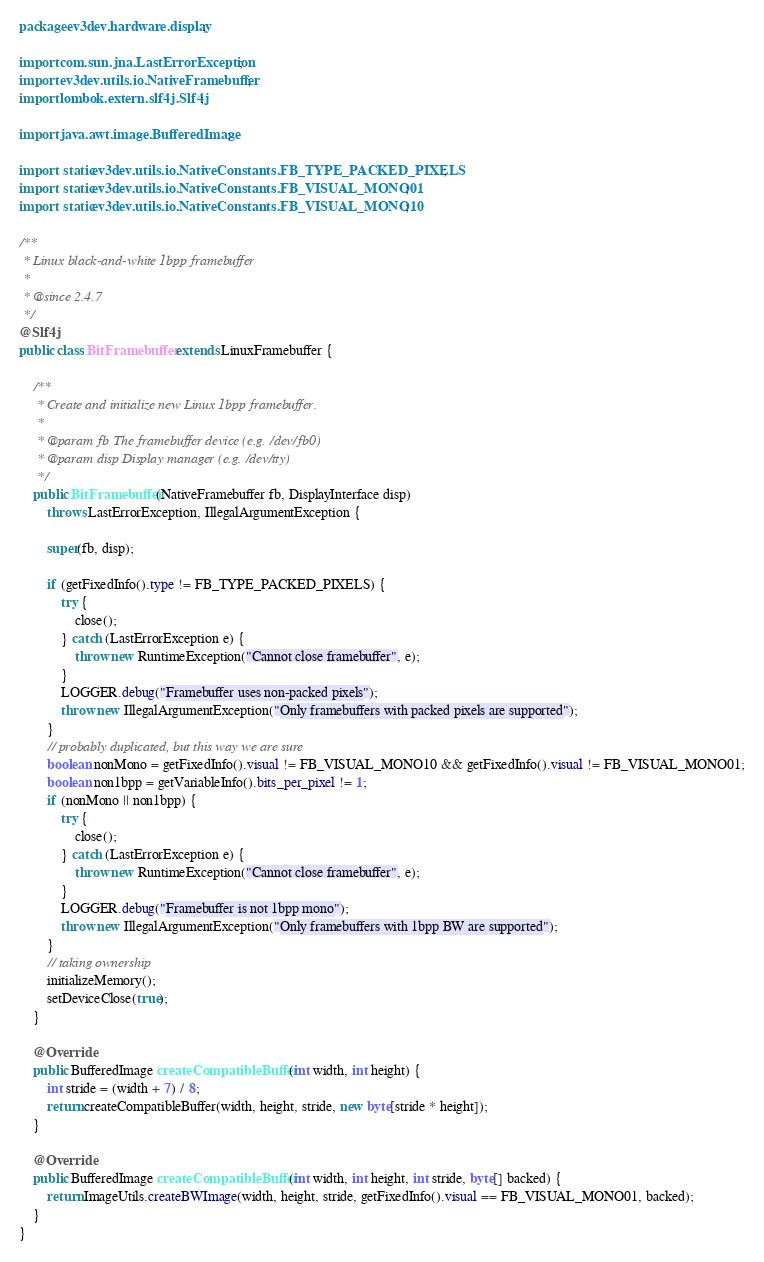<code> <loc_0><loc_0><loc_500><loc_500><_Java_>package ev3dev.hardware.display;

import com.sun.jna.LastErrorException;
import ev3dev.utils.io.NativeFramebuffer;
import lombok.extern.slf4j.Slf4j;

import java.awt.image.BufferedImage;

import static ev3dev.utils.io.NativeConstants.FB_TYPE_PACKED_PIXELS;
import static ev3dev.utils.io.NativeConstants.FB_VISUAL_MONO01;
import static ev3dev.utils.io.NativeConstants.FB_VISUAL_MONO10;

/**
 * Linux black-and-white 1bpp framebuffer
 *
 * @since 2.4.7
 */
@Slf4j
public class BitFramebuffer extends LinuxFramebuffer {

    /**
     * Create and initialize new Linux 1bpp framebuffer.
     *
     * @param fb The framebuffer device (e.g. /dev/fb0)
     * @param disp Display manager (e.g. /dev/tty)
     */
    public BitFramebuffer(NativeFramebuffer fb, DisplayInterface disp)
        throws LastErrorException, IllegalArgumentException {

        super(fb, disp);

        if (getFixedInfo().type != FB_TYPE_PACKED_PIXELS) {
            try {
                close();
            } catch (LastErrorException e) {
                throw new RuntimeException("Cannot close framebuffer", e);
            }
            LOGGER.debug("Framebuffer uses non-packed pixels");
            throw new IllegalArgumentException("Only framebuffers with packed pixels are supported");
        }
        // probably duplicated, but this way we are sure
        boolean nonMono = getFixedInfo().visual != FB_VISUAL_MONO10 && getFixedInfo().visual != FB_VISUAL_MONO01;
        boolean non1bpp = getVariableInfo().bits_per_pixel != 1;
        if (nonMono || non1bpp) {
            try {
                close();
            } catch (LastErrorException e) {
                throw new RuntimeException("Cannot close framebuffer", e);
            }
            LOGGER.debug("Framebuffer is not 1bpp mono");
            throw new IllegalArgumentException("Only framebuffers with 1bpp BW are supported");
        }
        // taking ownership
        initializeMemory();
        setDeviceClose(true);
    }

    @Override
    public BufferedImage createCompatibleBuffer(int width, int height) {
        int stride = (width + 7) / 8;
        return createCompatibleBuffer(width, height, stride, new byte[stride * height]);
    }

    @Override
    public BufferedImage createCompatibleBuffer(int width, int height, int stride, byte[] backed) {
        return ImageUtils.createBWImage(width, height, stride, getFixedInfo().visual == FB_VISUAL_MONO01, backed);
    }
}
</code> 